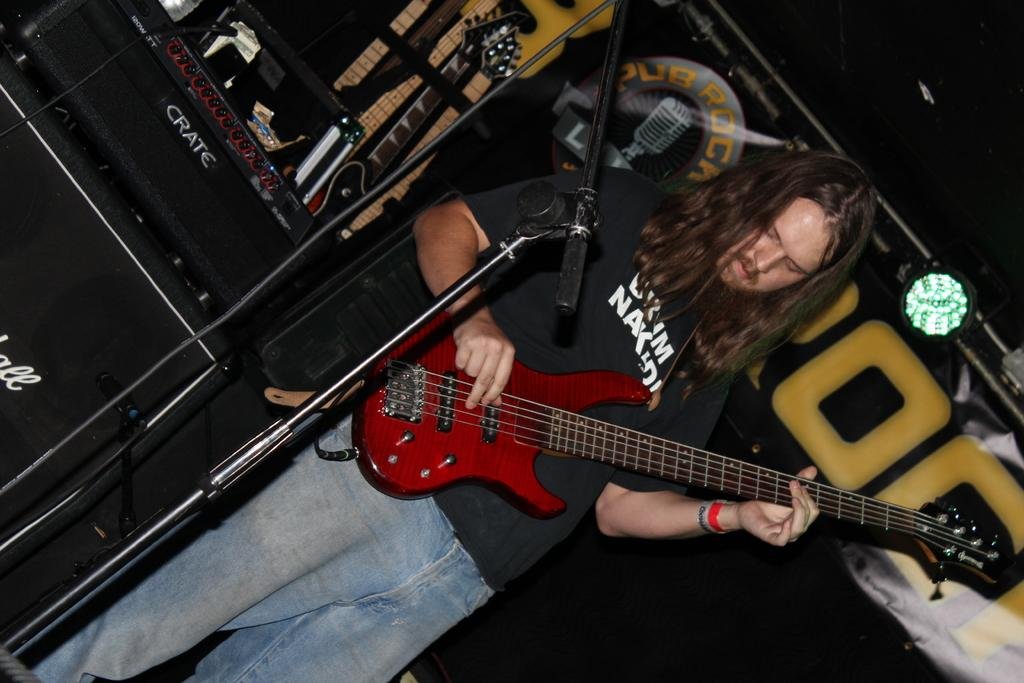What is the person in the image doing? The person is playing a guitar. What is the person wearing in the image? The person is wearing a black T-shirt. What object is in front of the person? There is a microphone in front of the person. What can be seen on the left side of the image? There is a sound box on the left side of the image. What type of quilt is being used to cover the guitar in the image? There is no quilt present in the image, and the guitar is not covered. 